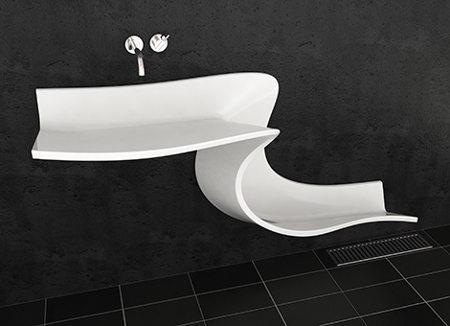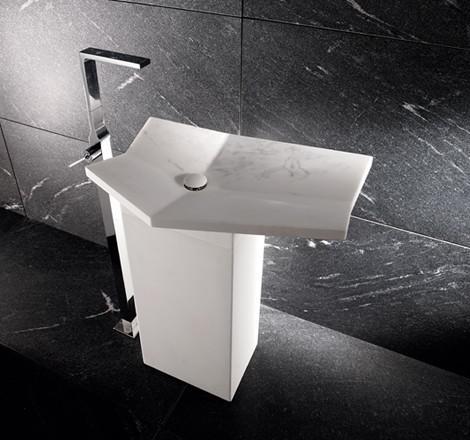The first image is the image on the left, the second image is the image on the right. Analyze the images presented: Is the assertion "There are two rectangular sinks with faucets attached to counter tops." valid? Answer yes or no. No. 